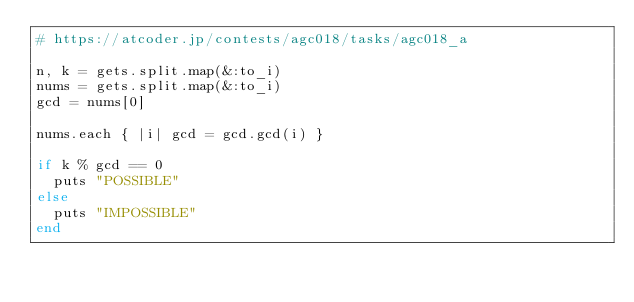Convert code to text. <code><loc_0><loc_0><loc_500><loc_500><_Ruby_># https://atcoder.jp/contests/agc018/tasks/agc018_a

n, k = gets.split.map(&:to_i)
nums = gets.split.map(&:to_i)
gcd = nums[0]

nums.each { |i| gcd = gcd.gcd(i) }

if k % gcd == 0
  puts "POSSIBLE"
else
  puts "IMPOSSIBLE"
end</code> 